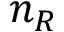<formula> <loc_0><loc_0><loc_500><loc_500>n _ { R }</formula> 